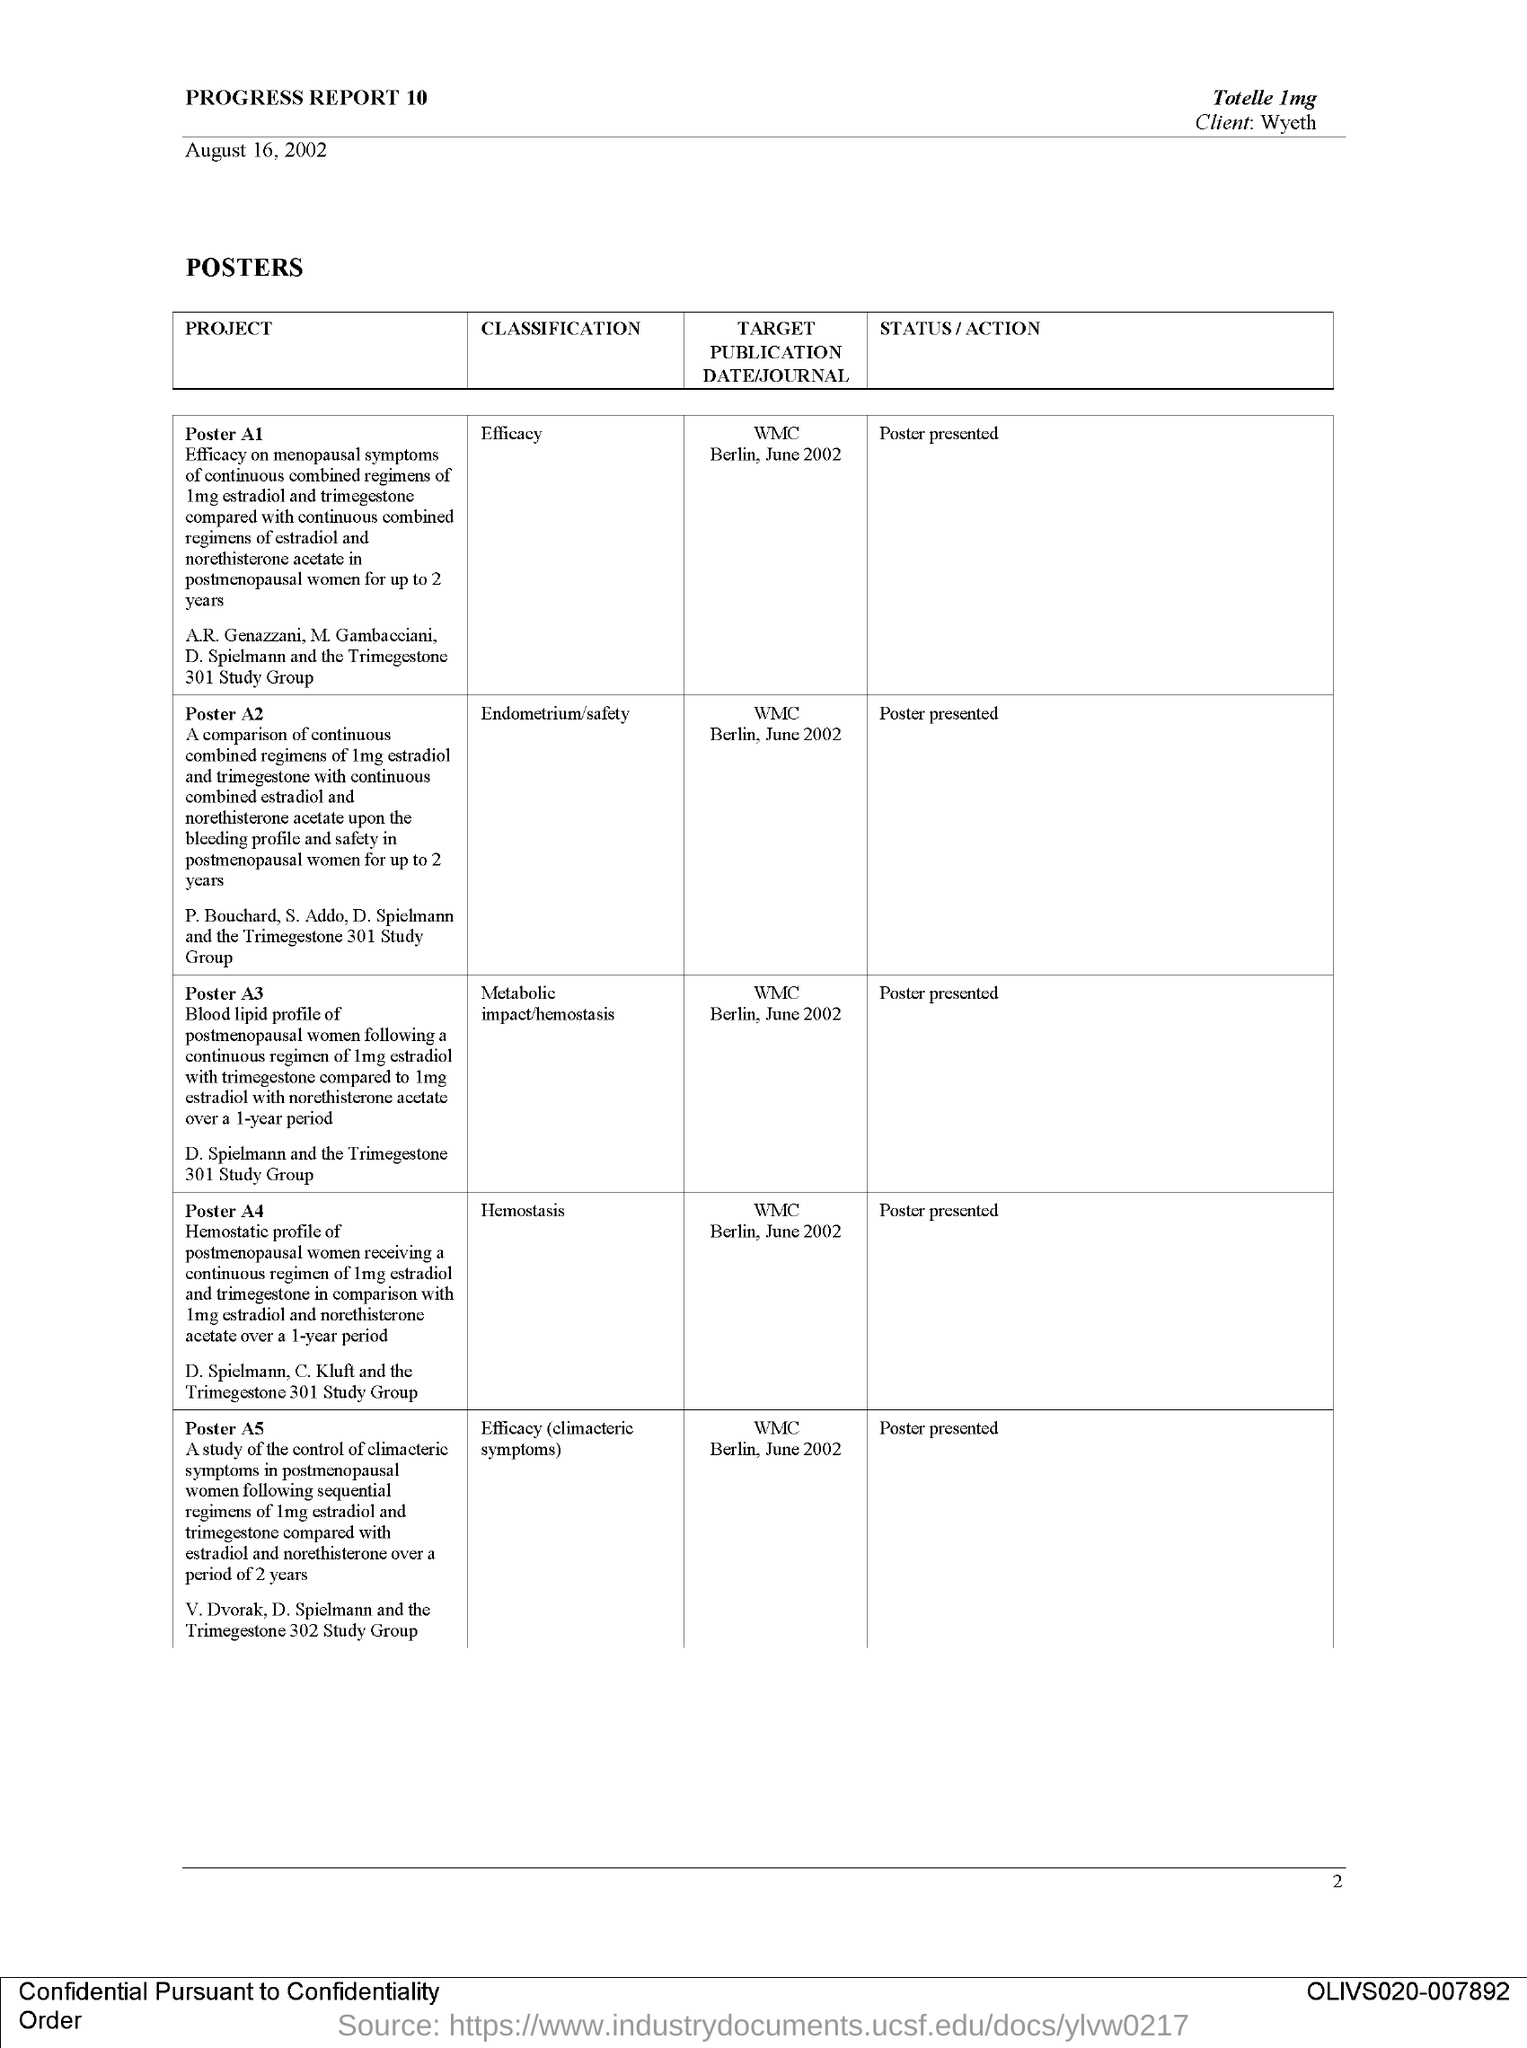What is the classification of the project poster a1 ?
Your answer should be compact. Efficacy. When is the target publication date /journal for the poster a 2 ?
Your answer should be compact. WMC BERLIN, JUNE 2002. What is the status /action for the poster a 1?
Your answer should be compact. POSTER PRESENTED. What is the status /action for the poster a 3?
Give a very brief answer. Poster presented. When is the target publication date /journal for the poster a 4 ?
Provide a short and direct response. WMC Berlin, June 2002. 